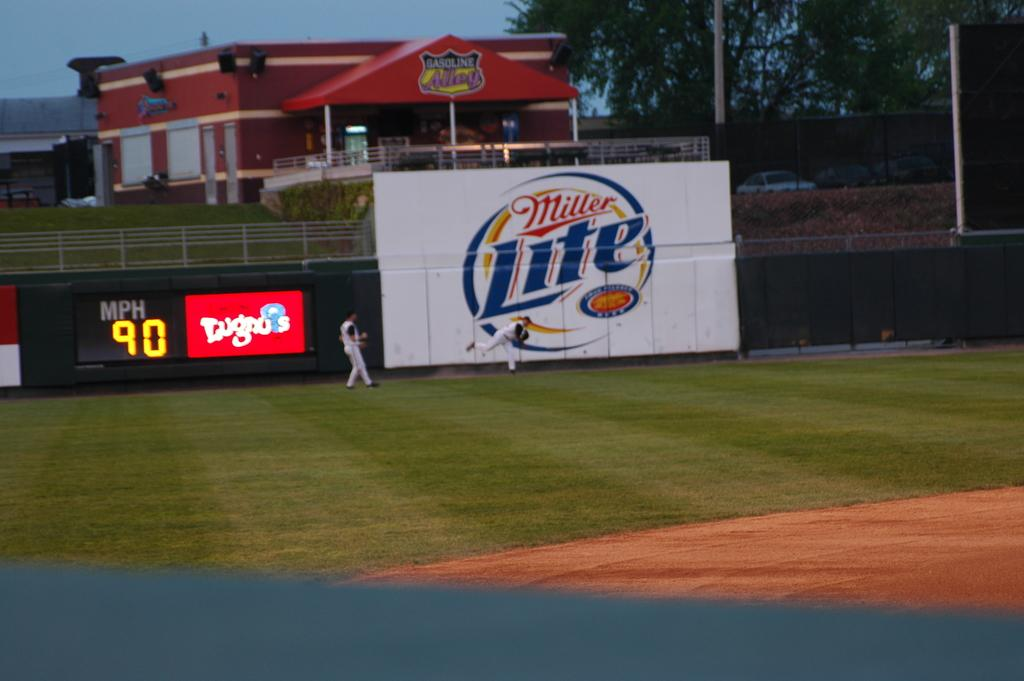What is happening on the ground in the image? There are people on the ground in the image. What can be seen in the background of the image? In the background of the image, there are boards, a scoreboard, a fence, vehicles, poles, buildings, and trees. Can you describe the setting of the image based on the background elements? The image appears to be set in an outdoor area with various structures and objects, such as a scoreboard, fence, and vehicles, suggesting it might be a sports or recreational facility. What type of tub is visible in the image? There is no tub present in the image. What is the mindset of the people on the ground in the image? The image does not provide information about the mindset of the people; it only shows their physical presence on the ground. 